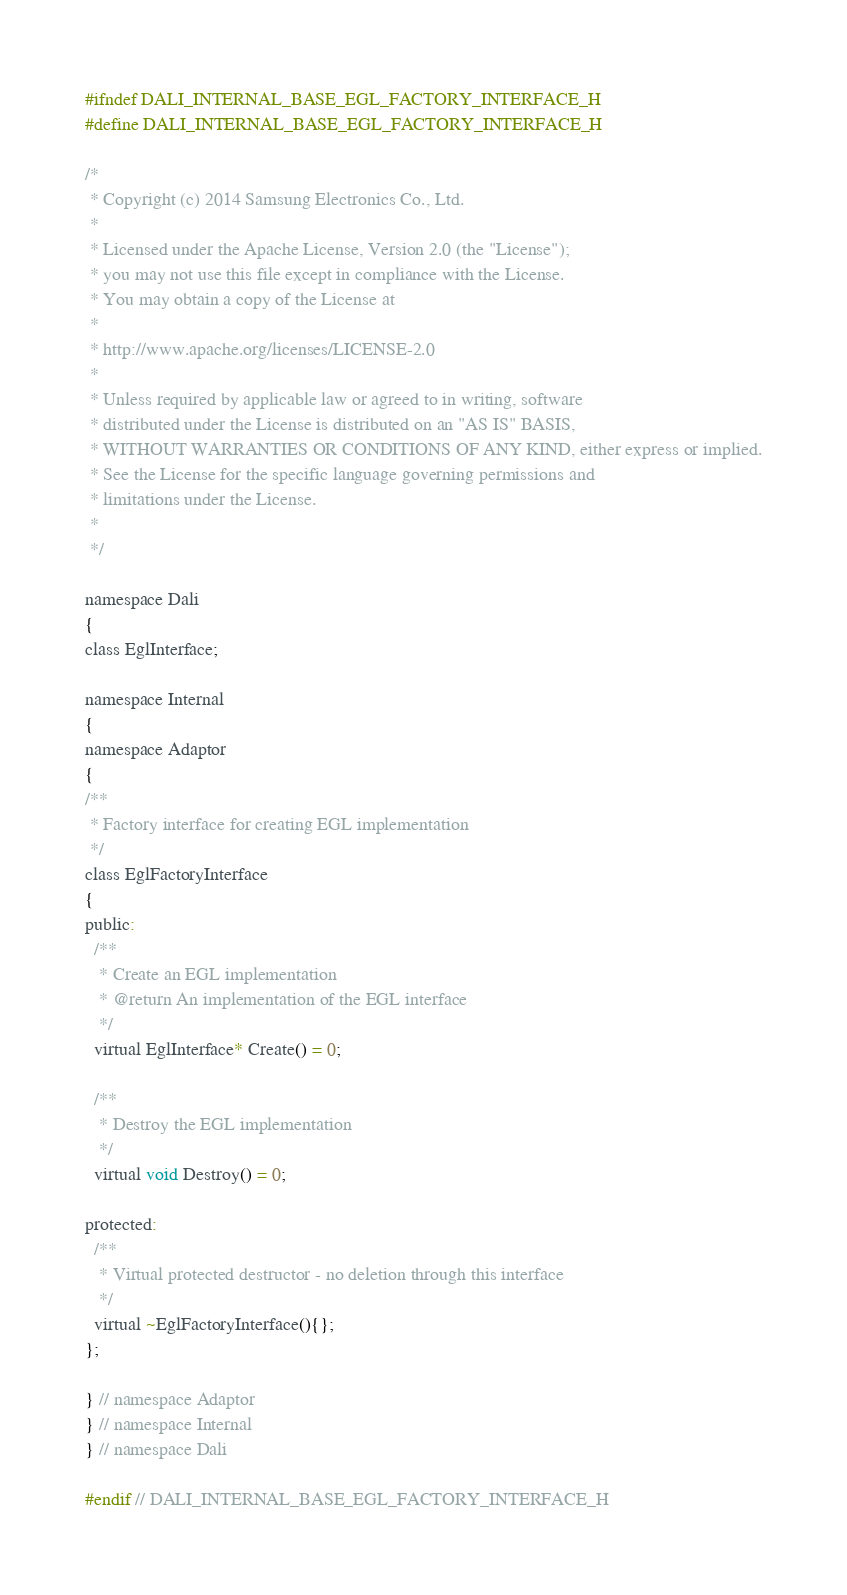<code> <loc_0><loc_0><loc_500><loc_500><_C_>#ifndef DALI_INTERNAL_BASE_EGL_FACTORY_INTERFACE_H
#define DALI_INTERNAL_BASE_EGL_FACTORY_INTERFACE_H

/*
 * Copyright (c) 2014 Samsung Electronics Co., Ltd.
 *
 * Licensed under the Apache License, Version 2.0 (the "License");
 * you may not use this file except in compliance with the License.
 * You may obtain a copy of the License at
 *
 * http://www.apache.org/licenses/LICENSE-2.0
 *
 * Unless required by applicable law or agreed to in writing, software
 * distributed under the License is distributed on an "AS IS" BASIS,
 * WITHOUT WARRANTIES OR CONDITIONS OF ANY KIND, either express or implied.
 * See the License for the specific language governing permissions and
 * limitations under the License.
 *
 */

namespace Dali
{
class EglInterface;

namespace Internal
{
namespace Adaptor
{
/**
 * Factory interface for creating EGL implementation
 */
class EglFactoryInterface
{
public:
  /**
   * Create an EGL implementation
   * @return An implementation of the EGL interface
   */
  virtual EglInterface* Create() = 0;

  /**
   * Destroy the EGL implementation
   */
  virtual void Destroy() = 0;

protected:
  /**
   * Virtual protected destructor - no deletion through this interface
   */
  virtual ~EglFactoryInterface(){};
};

} // namespace Adaptor
} // namespace Internal
} // namespace Dali

#endif // DALI_INTERNAL_BASE_EGL_FACTORY_INTERFACE_H
</code> 